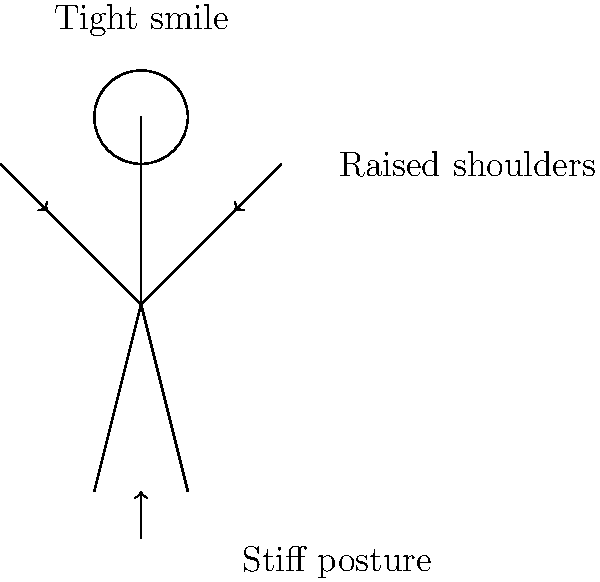As a celebrity attending a red carpet event, you notice a colleague exhibiting the body language depicted in the image. What emotional state does this body language most likely indicate? To interpret the body language shown in the image, let's analyze each element step-by-step:

1. Raised shoulders: The arrows pointing to the shoulders indicate they are raised. This often suggests tension or discomfort.

2. Tight smile: The label above the head mentions a "tight smile." A forced or tight smile typically indicates nervousness or anxiety rather than genuine happiness.

3. Stiff posture: The arrow pointing upwards at the figure's feet and the label "Stiff posture" suggest the person is standing rigidly. This is often a sign of nervousness or feeling uncomfortable.

4. Arms close to the body: The stick figure's arms are drawn close to the body, which can indicate a defensive or closed-off posture.

Combining these elements:
- Raised shoulders + stiff posture = Physical tension
- Tight smile = Forced pleasantry or masked discomfort
- Overall closed body language = Feeling vulnerable or uncomfortable

In the context of a red carpet event, where celebrities are expected to appear confident and at ease, this body language strongly suggests that the person is feeling anxious or uncomfortable despite trying to maintain a composed appearance.
Answer: Anxiety or discomfort 